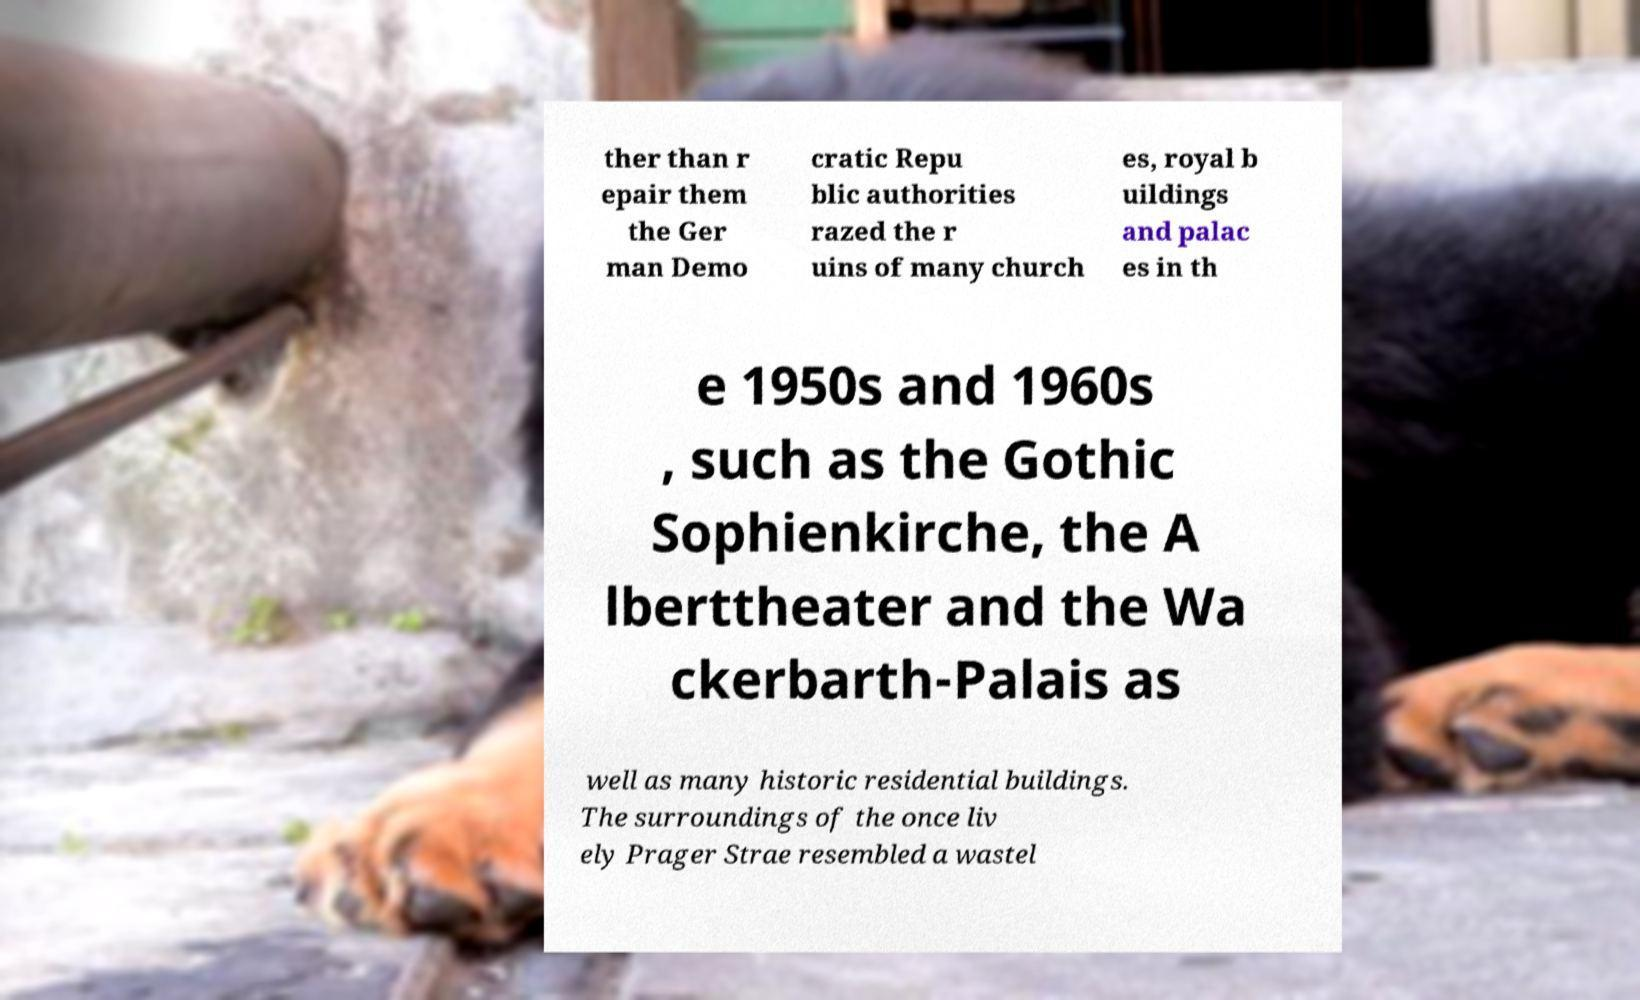What messages or text are displayed in this image? I need them in a readable, typed format. ther than r epair them the Ger man Demo cratic Repu blic authorities razed the r uins of many church es, royal b uildings and palac es in th e 1950s and 1960s , such as the Gothic Sophienkirche, the A lberttheater and the Wa ckerbarth-Palais as well as many historic residential buildings. The surroundings of the once liv ely Prager Strae resembled a wastel 